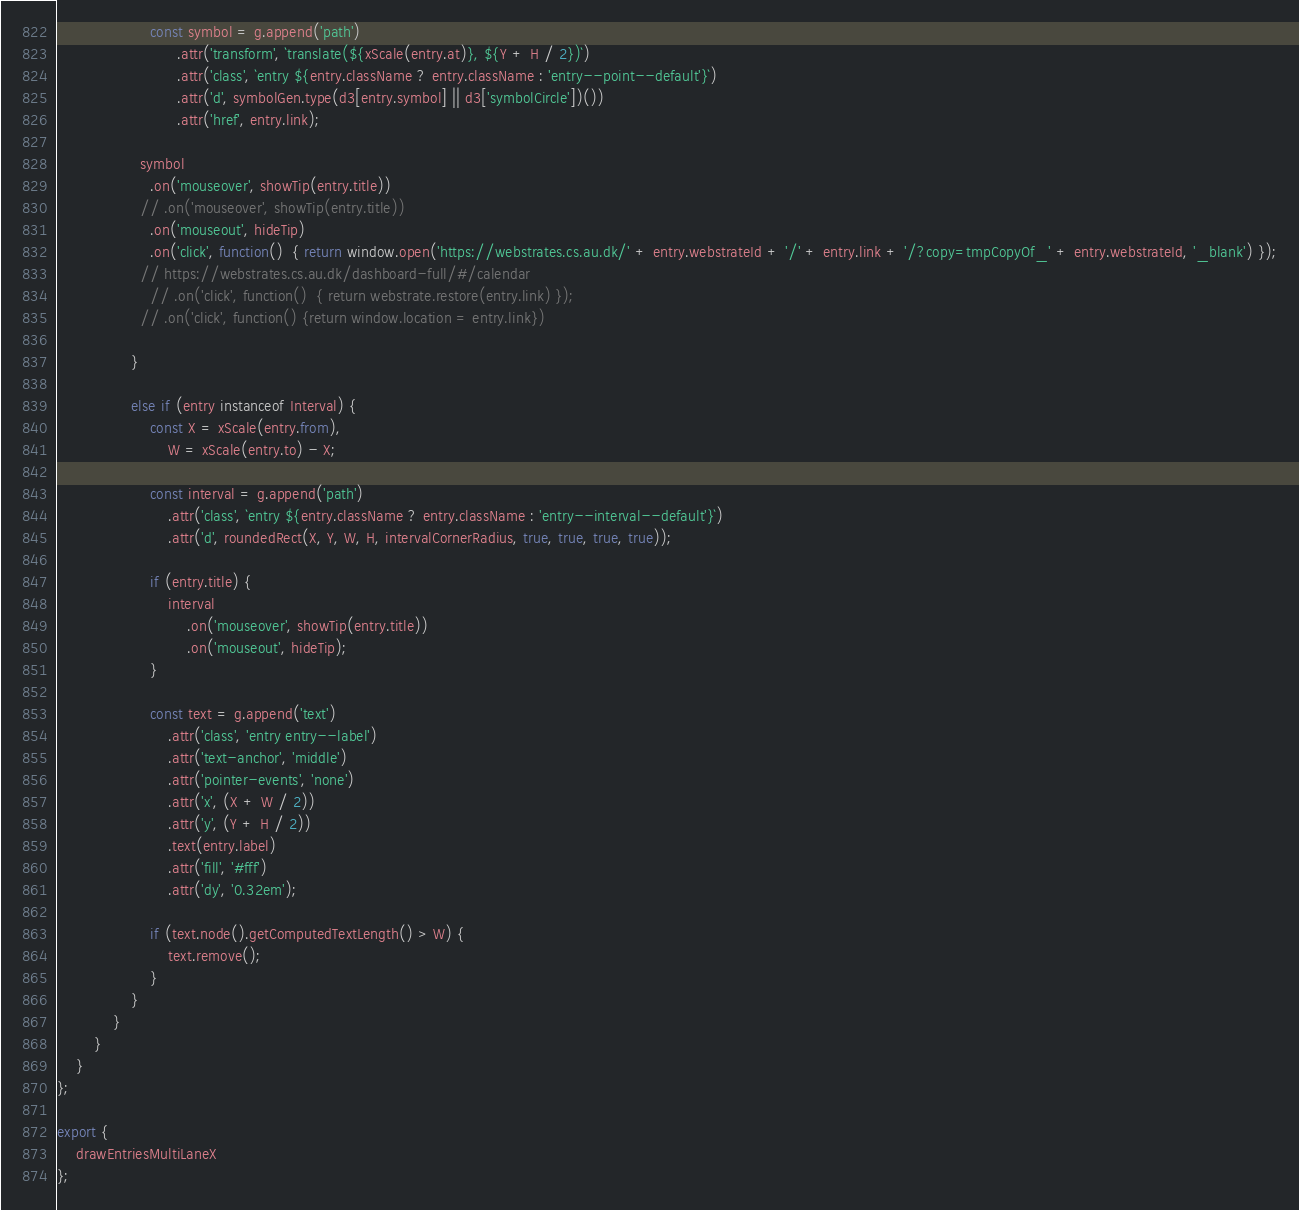Convert code to text. <code><loc_0><loc_0><loc_500><loc_500><_JavaScript_>
                    const symbol = g.append('path')
                          .attr('transform', `translate(${xScale(entry.at)}, ${Y + H / 2})`)
                          .attr('class', `entry ${entry.className ? entry.className : 'entry--point--default'}`)
                          .attr('d', symbolGen.type(d3[entry.symbol] || d3['symbolCircle'])())
                          .attr('href', entry.link); 

                  symbol
                    .on('mouseover', showTip(entry.title))
                  // .on('mouseover', showTip(entry.title))
                    .on('mouseout', hideTip)
                    .on('click', function()  { return window.open('https://webstrates.cs.au.dk/' + entry.webstrateId + '/' + entry.link + '/?copy=tmpCopyOf_' + entry.webstrateId, '_blank') });
                  // https://webstrates.cs.au.dk/dashboard-full/#/calendar
                    // .on('click', function()  { return webstrate.restore(entry.link) });
                  // .on('click', function() {return window.location = entry.link})
                  
                }

                else if (entry instanceof Interval) {
                    const X = xScale(entry.from),
                        W = xScale(entry.to) - X;

                    const interval = g.append('path')
                        .attr('class', `entry ${entry.className ? entry.className : 'entry--interval--default'}`)
                        .attr('d', roundedRect(X, Y, W, H, intervalCornerRadius, true, true, true, true));

                    if (entry.title) {
                        interval
                            .on('mouseover', showTip(entry.title))
                            .on('mouseout', hideTip);
                    }

                    const text = g.append('text')
                        .attr('class', 'entry entry--label')
                        .attr('text-anchor', 'middle')
                        .attr('pointer-events', 'none')
                        .attr('x', (X + W / 2))
                        .attr('y', (Y + H / 2))
                        .text(entry.label)
                        .attr('fill', '#fff')
                        .attr('dy', '0.32em');

                    if (text.node().getComputedTextLength() > W) {
                        text.remove();
                    }
                }
            }
        }
    }
};

export {
    drawEntriesMultiLaneX
};
</code> 